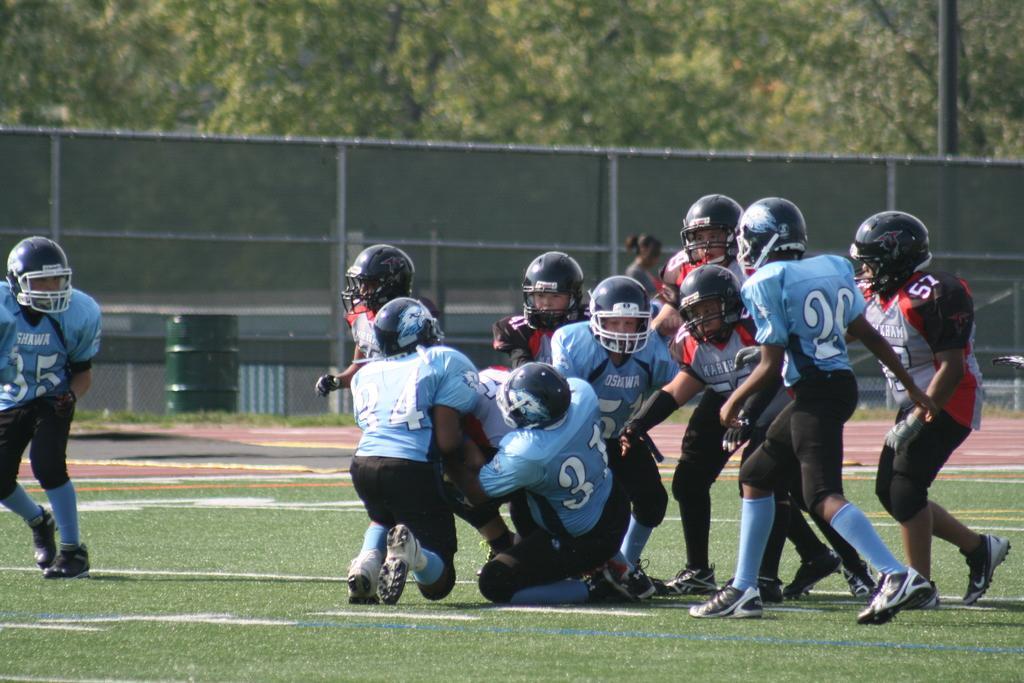Can you describe this image briefly? In the center of the image we can see a few people are in different costumes. And we can see they are wearing helmets. In the background, we can see trees, grass and a few other objects. 